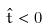<formula> <loc_0><loc_0><loc_500><loc_500>\hat { t } < 0</formula> 